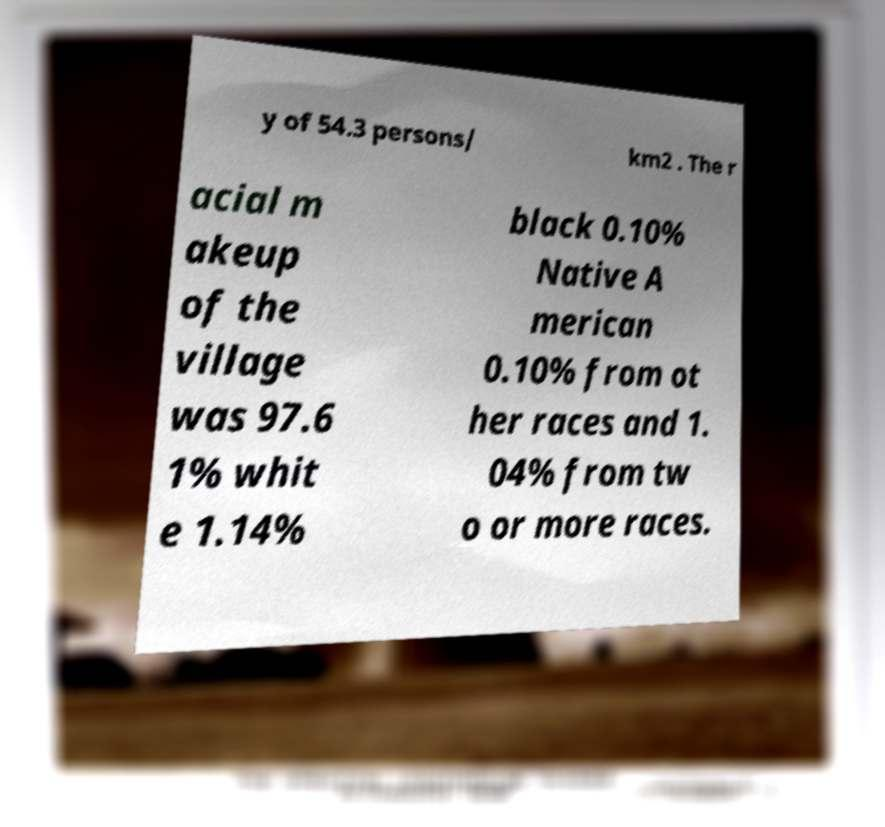Could you extract and type out the text from this image? y of 54.3 persons/ km2 . The r acial m akeup of the village was 97.6 1% whit e 1.14% black 0.10% Native A merican 0.10% from ot her races and 1. 04% from tw o or more races. 